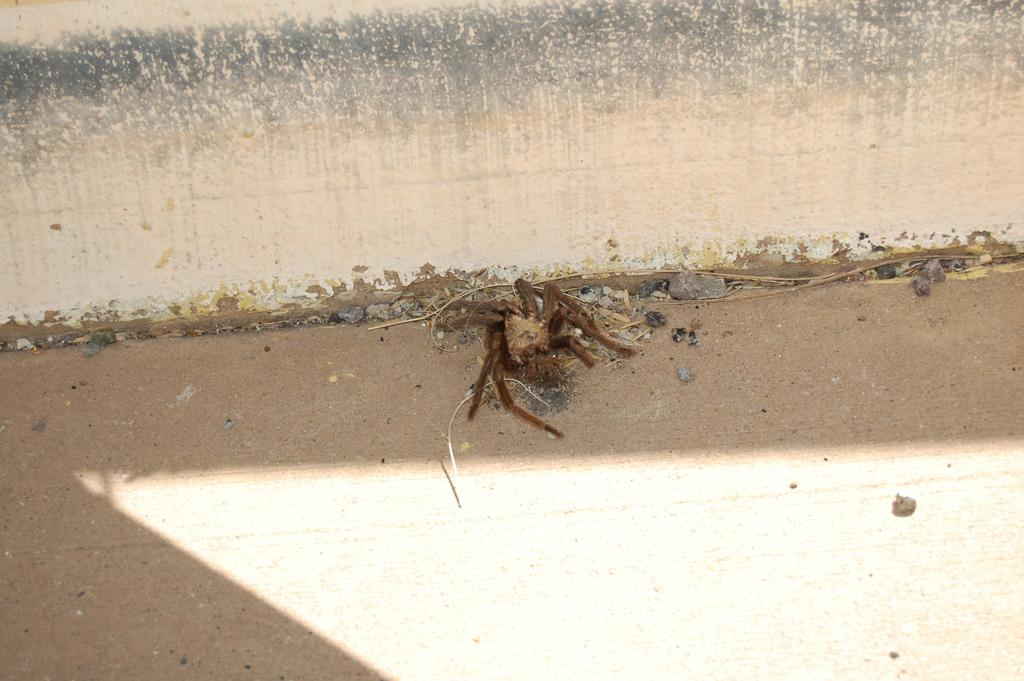What type of surface can be seen in the image? There is a cream and black colored surface in the image. What is the color of the insect in the image? The insect is brown and cream in color. What type of terrain is visible in the image? Ground is visible in the image. What other objects can be seen in the image? There are small stones in the image. Where is the kitty playing with jelly in the image? There is no kitty or jelly present in the image. What type of dirt is visible in the image? There is no dirt visible in the image; only ground, an insect, a colored surface, and small stones are present. 